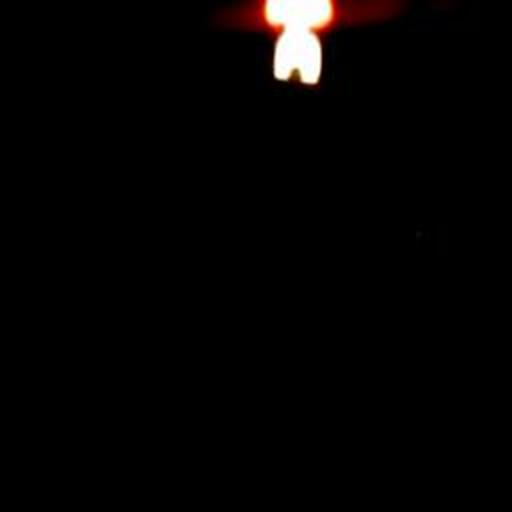What is the source of light in the image? The image showcases a singular light source that appears to be a flame, possibly from a candle or small fire, that contrasts sharply with the surrounding darkness. 